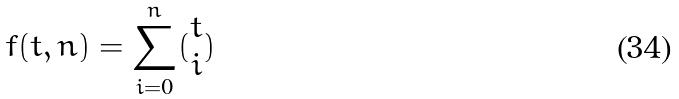<formula> <loc_0><loc_0><loc_500><loc_500>f ( t , n ) = \sum _ { i = 0 } ^ { n } ( \begin{matrix} t \\ i \end{matrix} )</formula> 